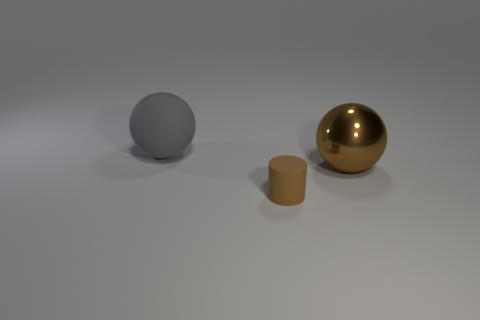Are there any big matte objects that have the same color as the big matte sphere?
Make the answer very short. No. What number of small things are brown matte things or balls?
Keep it short and to the point. 1. Do the sphere that is left of the small brown rubber thing and the large brown thing have the same material?
Your answer should be very brief. No. There is a brown thing in front of the large sphere to the right of the sphere on the left side of the small brown rubber object; what shape is it?
Provide a succinct answer. Cylinder. What number of brown things are either large objects or large matte objects?
Your answer should be compact. 1. Are there the same number of big gray objects right of the big rubber sphere and tiny cylinders that are right of the small matte thing?
Your answer should be very brief. Yes. Is the shape of the object in front of the big brown metallic thing the same as the big thing that is on the left side of the big metal thing?
Your response must be concise. No. Are there any other things that have the same shape as the large brown thing?
Make the answer very short. Yes. The large gray thing that is the same material as the brown cylinder is what shape?
Give a very brief answer. Sphere. Are there the same number of things that are in front of the brown metallic object and big spheres?
Your answer should be compact. No. 